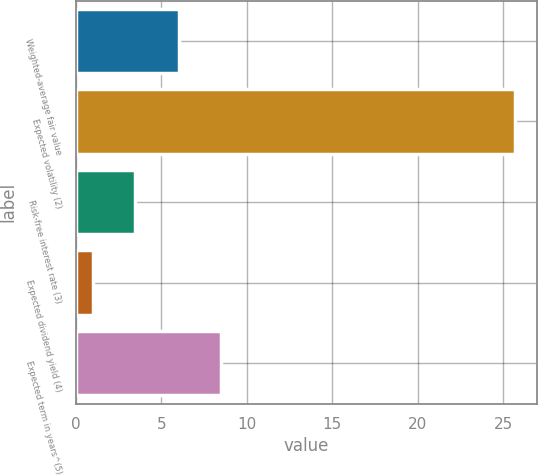Convert chart to OTSL. <chart><loc_0><loc_0><loc_500><loc_500><bar_chart><fcel>Weighted-average fair value<fcel>Expected volatility (2)<fcel>Risk-free interest rate (3)<fcel>Expected dividend yield (4)<fcel>Expected term in years^(5)<nl><fcel>6<fcel>25.7<fcel>3.47<fcel>1<fcel>8.47<nl></chart> 